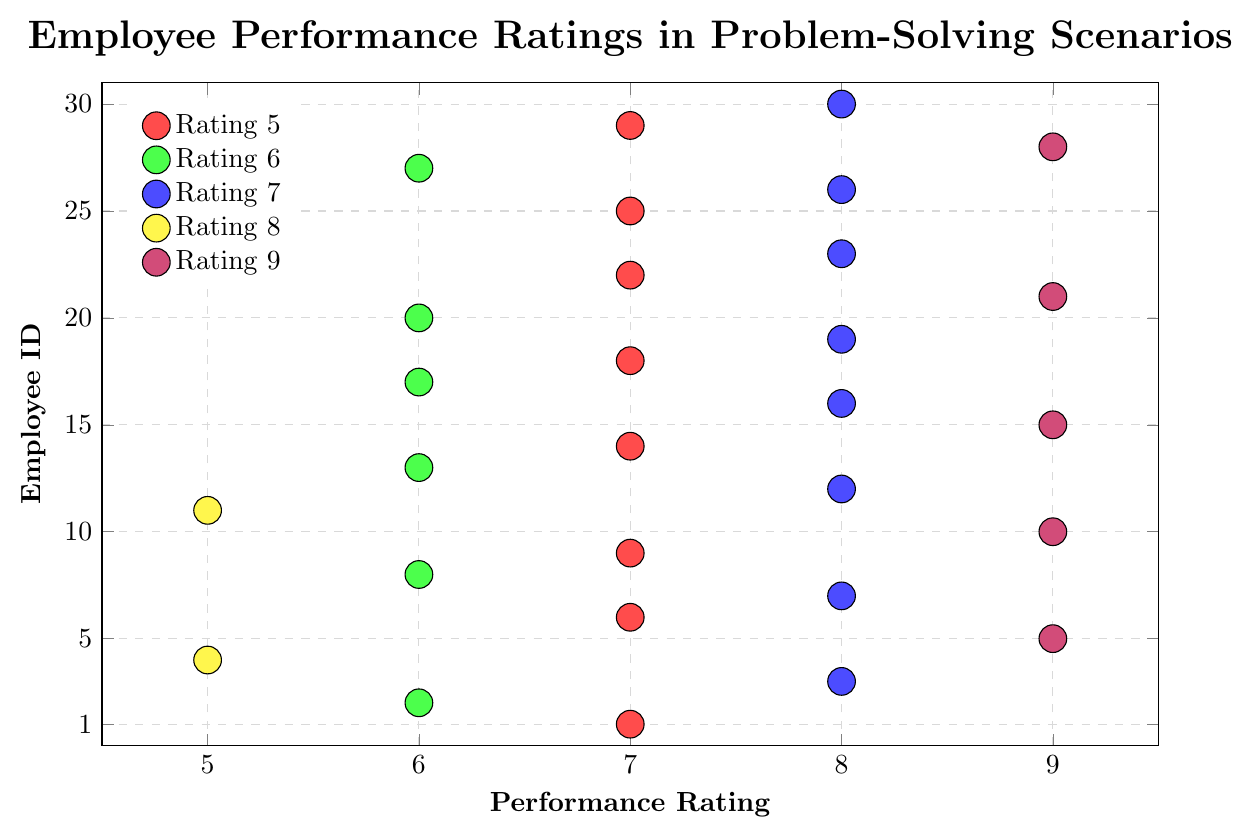Which performance rating has the highest number of employees? By looking at the clusters of dots, the performance rating of 8 has the highest number of employees since there are many dots concentrated in that vertical line.
Answer: 8 How many employees received a performance rating of 9? Count the dots aligned vertically at the performance rating of 9. There are 6 dots.
Answer: 6 What is the difference in the number of employees between performance ratings 5 and 6? Count the dots for performance rating 5 (3 dots) and for performance rating 6 (7 dots), then calculate the difference, which is 7 - 3.
Answer: 4 Are there more employees with a performance rating of 7 than 8? Count the dots for performance rating 7 (8 dots) and for performance rating 8 (8 dots), then compare the numbers. Both have the same count.
Answer: No Which color represents the performance rating of 6? Look at the legend and find the color associated with performance rating 6, which is green.
Answer: Green What is the average performance rating among all employees? Add all performance ratings (7+6+8+5+9...+8) to get 202, then divide by the number of employees (30). The average is 202/30.
Answer: 6.73 How many employees received a performance rating of at least 8? Count the dots for performance ratings 8 and 9, which are 10 (8's) and 6 (9's). The total is 10 + 6.
Answer: 16 Which performance rating has the fewest employees? Look at the clusters of dots to identify the sparsest column. Performance rating 5 has only 3 dots.
Answer: 5 Which performance rating represents the purple color? Refer to the legend, which indicates that purple is associated with a rating of 9.
Answer: 9 What is the median performance rating? Rank all performance ratings and find the middle value. With 30 ratings, the 15th and 16th values after sorting are both 7.
Answer: 7 